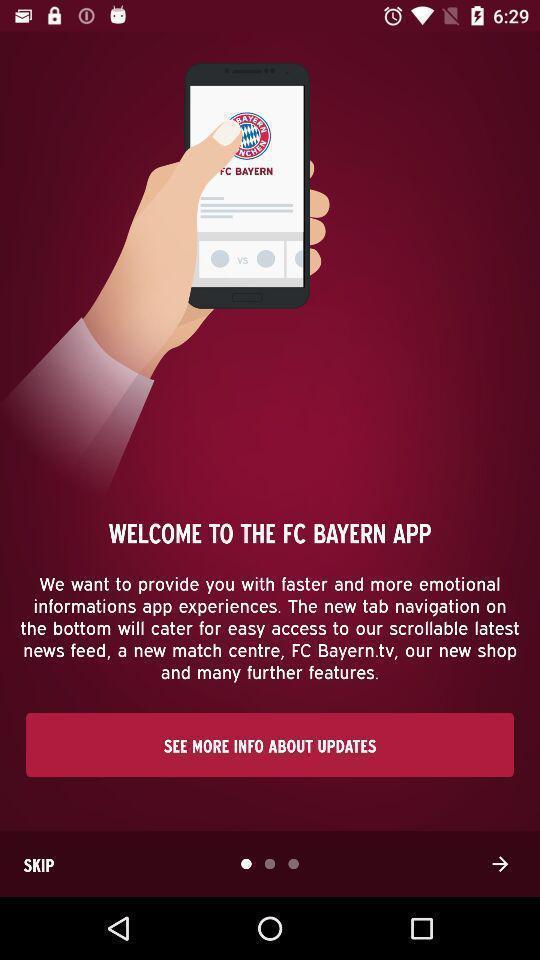Describe the visual elements of this screenshot. Welcome page showing to proceed next. 